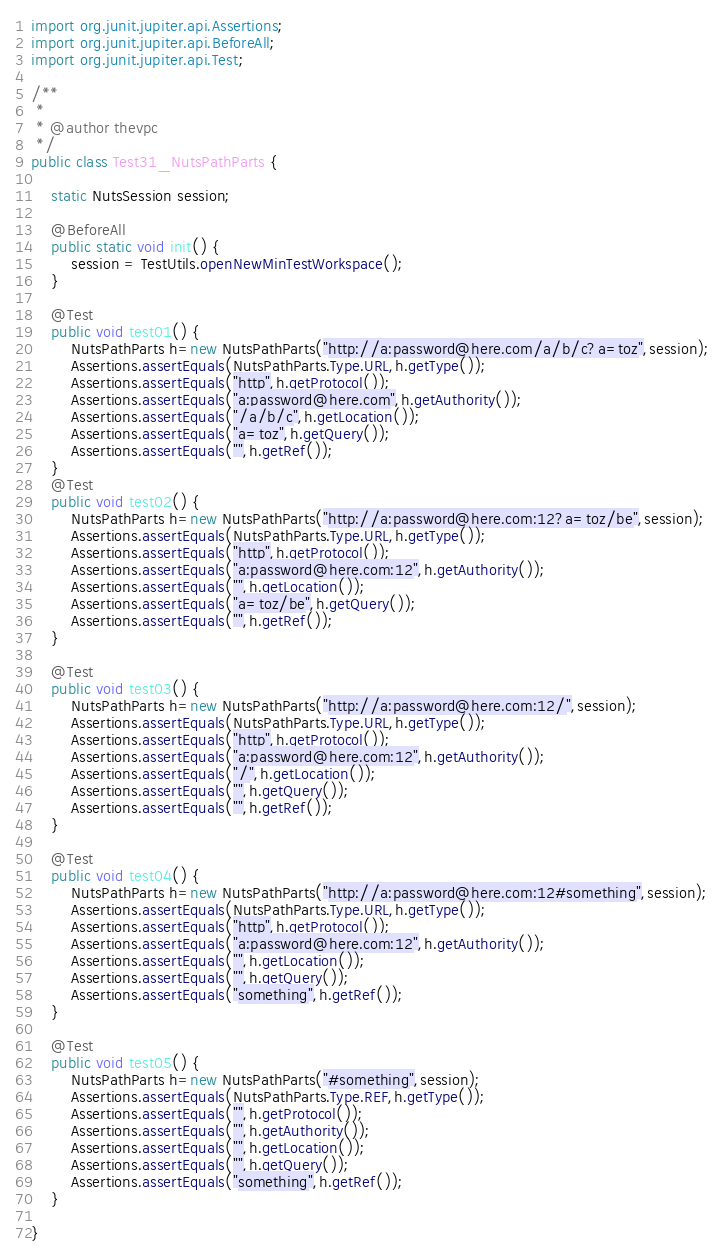Convert code to text. <code><loc_0><loc_0><loc_500><loc_500><_Java_>import org.junit.jupiter.api.Assertions;
import org.junit.jupiter.api.BeforeAll;
import org.junit.jupiter.api.Test;

/**
 *
 * @author thevpc
 */
public class Test31_NutsPathParts {

    static NutsSession session;

    @BeforeAll
    public static void init() {
        session = TestUtils.openNewMinTestWorkspace();
    }

    @Test
    public void test01() {
        NutsPathParts h=new NutsPathParts("http://a:password@here.com/a/b/c?a=toz",session);
        Assertions.assertEquals(NutsPathParts.Type.URL,h.getType());
        Assertions.assertEquals("http",h.getProtocol());
        Assertions.assertEquals("a:password@here.com",h.getAuthority());
        Assertions.assertEquals("/a/b/c",h.getLocation());
        Assertions.assertEquals("a=toz",h.getQuery());
        Assertions.assertEquals("",h.getRef());
    }
    @Test
    public void test02() {
        NutsPathParts h=new NutsPathParts("http://a:password@here.com:12?a=toz/be",session);
        Assertions.assertEquals(NutsPathParts.Type.URL,h.getType());
        Assertions.assertEquals("http",h.getProtocol());
        Assertions.assertEquals("a:password@here.com:12",h.getAuthority());
        Assertions.assertEquals("",h.getLocation());
        Assertions.assertEquals("a=toz/be",h.getQuery());
        Assertions.assertEquals("",h.getRef());
    }

    @Test
    public void test03() {
        NutsPathParts h=new NutsPathParts("http://a:password@here.com:12/",session);
        Assertions.assertEquals(NutsPathParts.Type.URL,h.getType());
        Assertions.assertEquals("http",h.getProtocol());
        Assertions.assertEquals("a:password@here.com:12",h.getAuthority());
        Assertions.assertEquals("/",h.getLocation());
        Assertions.assertEquals("",h.getQuery());
        Assertions.assertEquals("",h.getRef());
    }

    @Test
    public void test04() {
        NutsPathParts h=new NutsPathParts("http://a:password@here.com:12#something",session);
        Assertions.assertEquals(NutsPathParts.Type.URL,h.getType());
        Assertions.assertEquals("http",h.getProtocol());
        Assertions.assertEquals("a:password@here.com:12",h.getAuthority());
        Assertions.assertEquals("",h.getLocation());
        Assertions.assertEquals("",h.getQuery());
        Assertions.assertEquals("something",h.getRef());
    }

    @Test
    public void test05() {
        NutsPathParts h=new NutsPathParts("#something",session);
        Assertions.assertEquals(NutsPathParts.Type.REF,h.getType());
        Assertions.assertEquals("",h.getProtocol());
        Assertions.assertEquals("",h.getAuthority());
        Assertions.assertEquals("",h.getLocation());
        Assertions.assertEquals("",h.getQuery());
        Assertions.assertEquals("something",h.getRef());
    }

}
</code> 